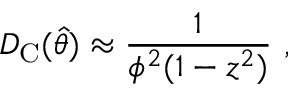<formula> <loc_0><loc_0><loc_500><loc_500>D _ { C } ( \hat { \theta } ) \approx \frac { 1 } { \phi ^ { 2 } ( 1 - z ^ { 2 } ) } \ ,</formula> 